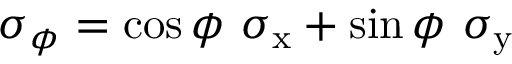Convert formula to latex. <formula><loc_0><loc_0><loc_500><loc_500>\sigma _ { \phi } = \cos \phi \sigma _ { x } + \sin \phi \sigma _ { y }</formula> 